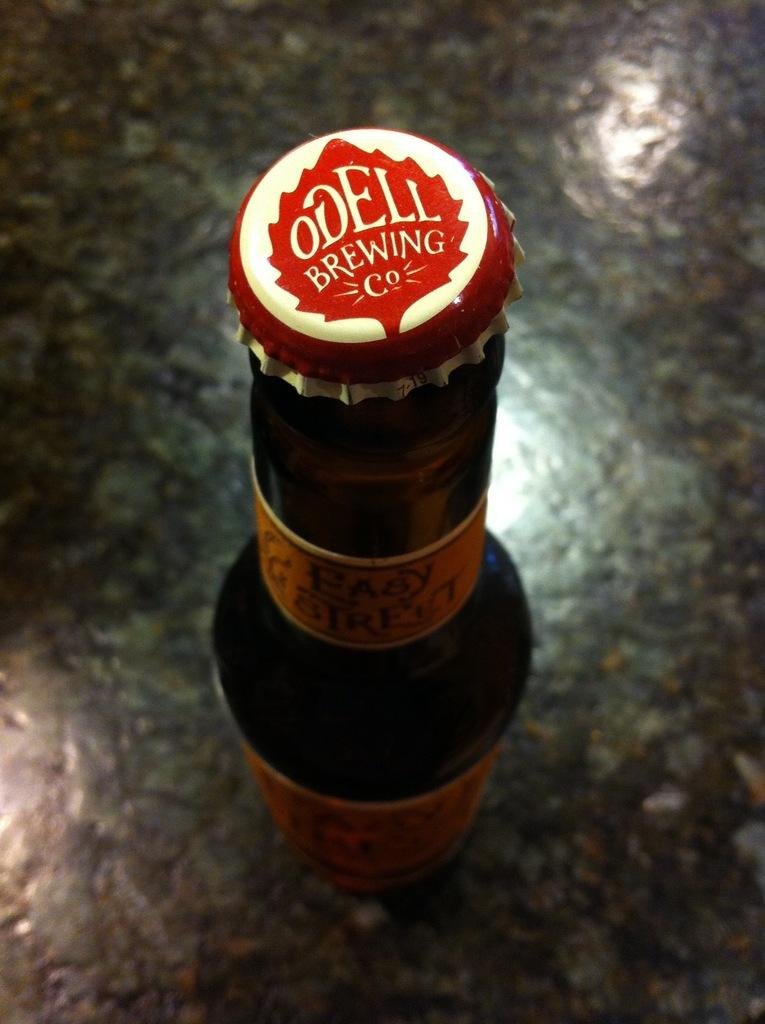<image>
Share a concise interpretation of the image provided. A bottle of Odell brewing  on top of a counter. 